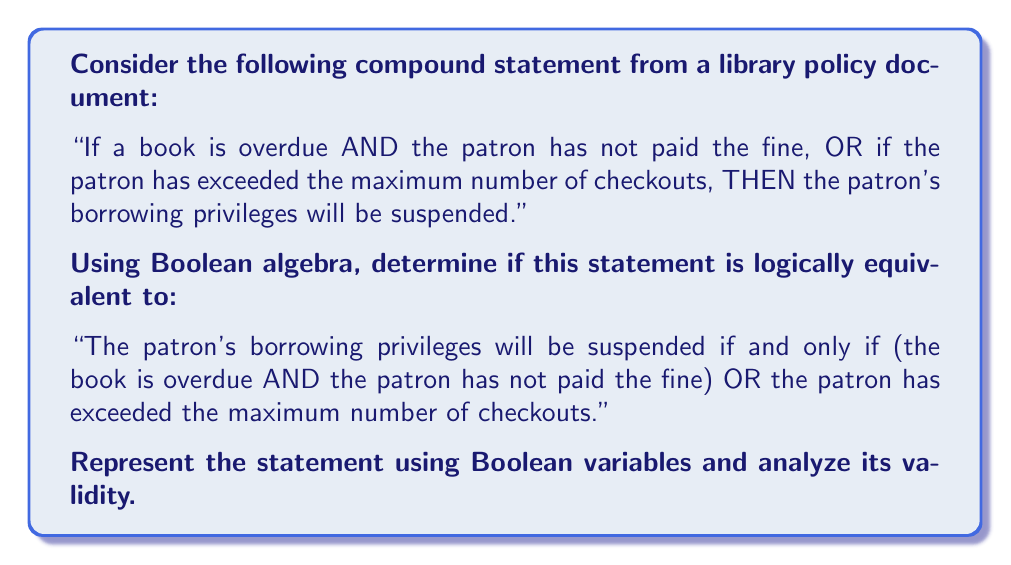Show me your answer to this math problem. Let's break this down step-by-step using Boolean algebra:

1. Define Boolean variables:
   $A$: The book is overdue
   $B$: The patron has not paid the fine
   $C$: The patron has exceeded the maximum number of checkouts
   $S$: The patron's borrowing privileges will be suspended

2. Express the original statement in Boolean algebra:
   $S = ((A \land B) \lor C)$

3. Express the statement to be compared in Boolean algebra:
   $S \iff ((A \land B) \lor C)$

4. To prove logical equivalence, we need to show that these statements are the same. We can do this by creating a truth table for both expressions and comparing the results.

5. Truth table:

   $$
   \begin{array}{|c|c|c|c|c|c|}
   \hline
   A & B & C & A \land B & (A \land B) \lor C & S \iff ((A \land B) \lor C) \\
   \hline
   0 & 0 & 0 & 0 & 0 & 1 \\
   0 & 0 & 1 & 0 & 1 & 1 \\
   0 & 1 & 0 & 0 & 0 & 1 \\
   0 & 1 & 1 & 0 & 1 & 1 \\
   1 & 0 & 0 & 0 & 0 & 1 \\
   1 & 0 & 1 & 0 & 1 & 1 \\
   1 & 1 & 0 & 1 & 1 & 1 \\
   1 & 1 & 1 & 1 & 1 & 1 \\
   \hline
   \end{array}
   $$

6. Analyzing the truth table:
   - The column $((A \land B) \lor C)$ represents the original statement.
   - The column $S \iff ((A \land B) \lor C)$ represents the statement to be compared.

7. We can see that the last column (the comparison) is always true (1) for all possible combinations of $A$, $B$, and $C$.

8. This means that the original statement and the statement to be compared are logically equivalent.

Therefore, the compound statement from the library policy document is indeed logically equivalent to the given comparison statement.
Answer: The statements are logically equivalent. 